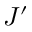Convert formula to latex. <formula><loc_0><loc_0><loc_500><loc_500>J ^ { \prime }</formula> 